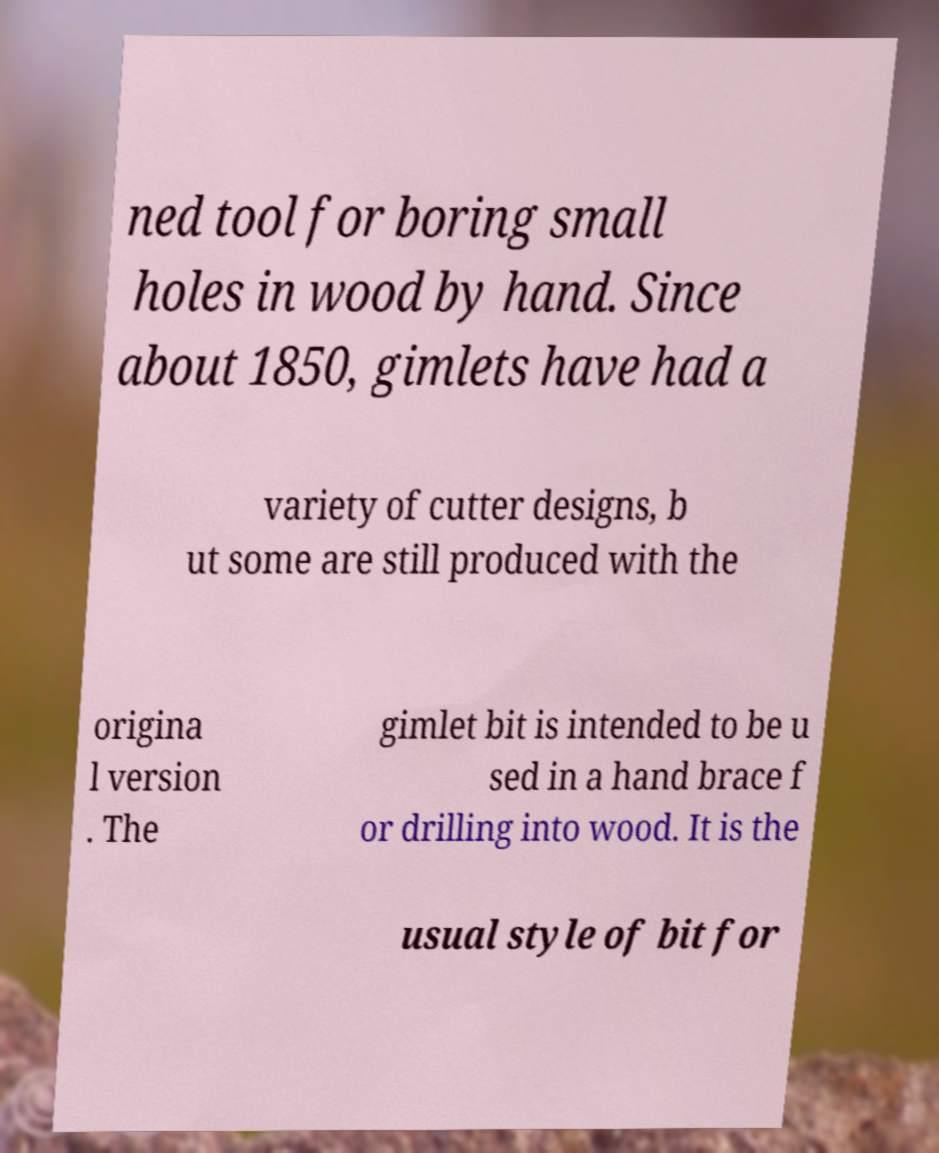Could you assist in decoding the text presented in this image and type it out clearly? ned tool for boring small holes in wood by hand. Since about 1850, gimlets have had a variety of cutter designs, b ut some are still produced with the origina l version . The gimlet bit is intended to be u sed in a hand brace f or drilling into wood. It is the usual style of bit for 